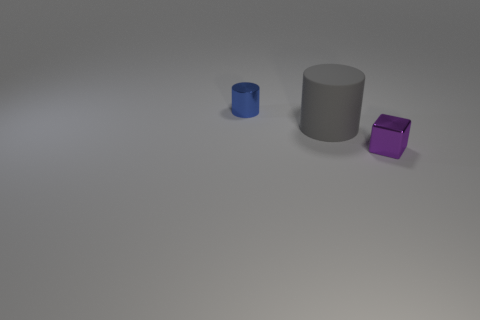There is a cylinder in front of the tiny metal cylinder; what is its material?
Provide a short and direct response. Rubber. What number of other things are there of the same size as the matte cylinder?
Provide a succinct answer. 0. Are there fewer small purple objects than tiny red metallic cylinders?
Provide a succinct answer. No. What is the shape of the blue metal object?
Offer a terse response. Cylinder. There is a thing that is on the right side of the small metallic cylinder and behind the small block; what is its shape?
Your answer should be compact. Cylinder. There is a shiny thing that is on the left side of the large gray cylinder; what is its color?
Offer a very short reply. Blue. Do the purple object and the blue shiny thing have the same size?
Your answer should be compact. Yes. There is a thing that is both on the left side of the purple metallic object and in front of the metal cylinder; how big is it?
Keep it short and to the point. Large. What number of tiny blue objects are the same material as the purple cube?
Your answer should be compact. 1. The small metallic cube has what color?
Your answer should be compact. Purple. 